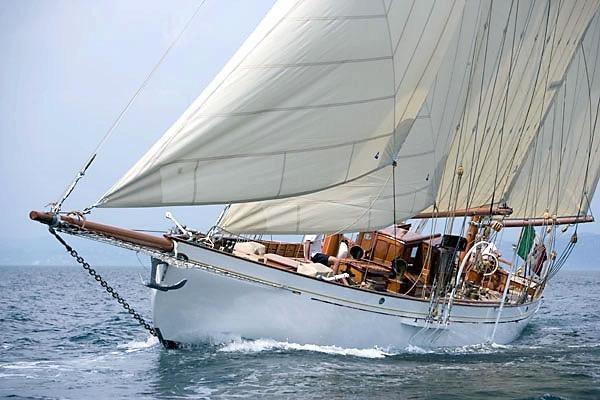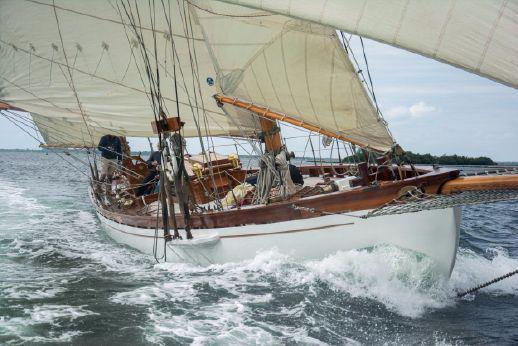The first image is the image on the left, the second image is the image on the right. Considering the images on both sides, is "The image on the left has a boat with at least three of its sails engaged." valid? Answer yes or no. Yes. 